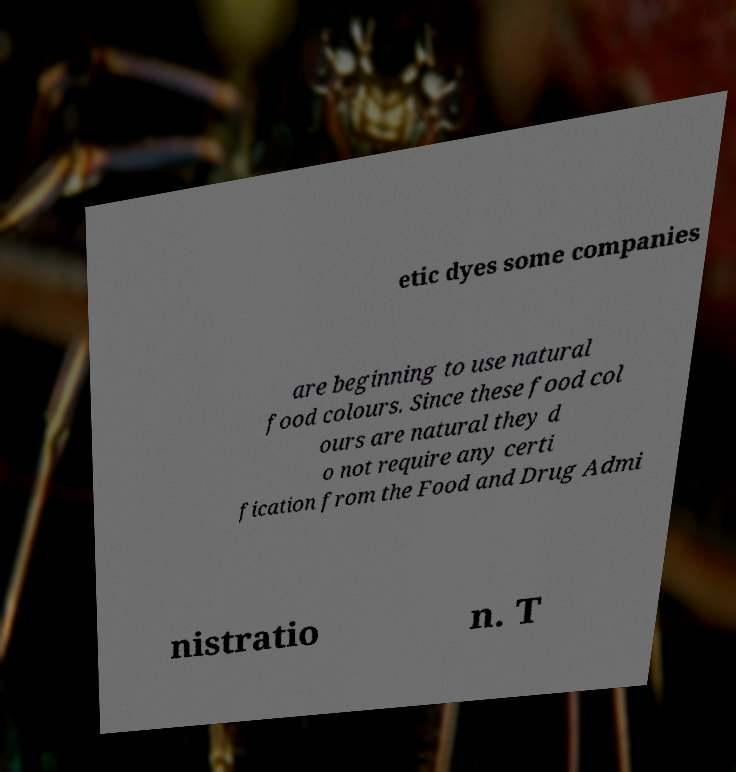Could you assist in decoding the text presented in this image and type it out clearly? etic dyes some companies are beginning to use natural food colours. Since these food col ours are natural they d o not require any certi fication from the Food and Drug Admi nistratio n. T 